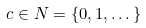Convert formula to latex. <formula><loc_0><loc_0><loc_500><loc_500>c \in N = \{ 0 , 1 , \dots \}</formula> 